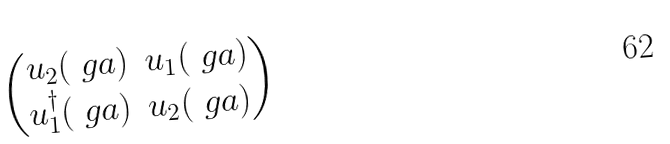Convert formula to latex. <formula><loc_0><loc_0><loc_500><loc_500>\begin{pmatrix} u _ { 2 } ( \ g a ) & u _ { 1 } ( \ g a ) \\ u _ { 1 } ^ { \dagger } ( \ g a ) & u _ { 2 } ( \ g a ) \end{pmatrix}</formula> 